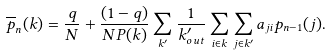<formula> <loc_0><loc_0><loc_500><loc_500>\overline { p } _ { n } ( { k } ) = \frac { q } { N } + \frac { ( 1 - q ) } { N P ( { k } ) } \sum _ { k ^ { \prime } } \frac { 1 } { k ^ { \prime } _ { o u t } } \sum _ { i \in { k } } \sum _ { j \in { k ^ { \prime } } } a _ { j i } p _ { n - 1 } ( j ) .</formula> 